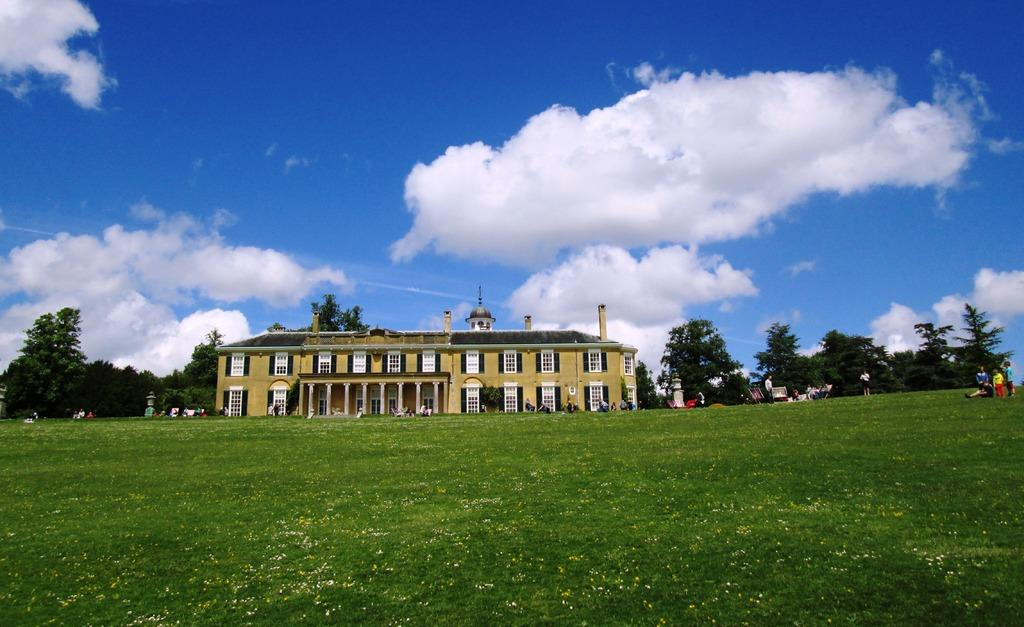What is the main setting of the image? There is an open grass ground in the image. What is happening on the grass ground? There are people on the grass ground. What can be seen in the background of the image? There is a yellow-colored building, trees, clouds, and the sky visible in the background. What type of dinner is being served on the grass ground in the image? There is no dinner present in the image; it features an open grass ground with people and a background with a yellow-colored building, trees, clouds, and the sky. 